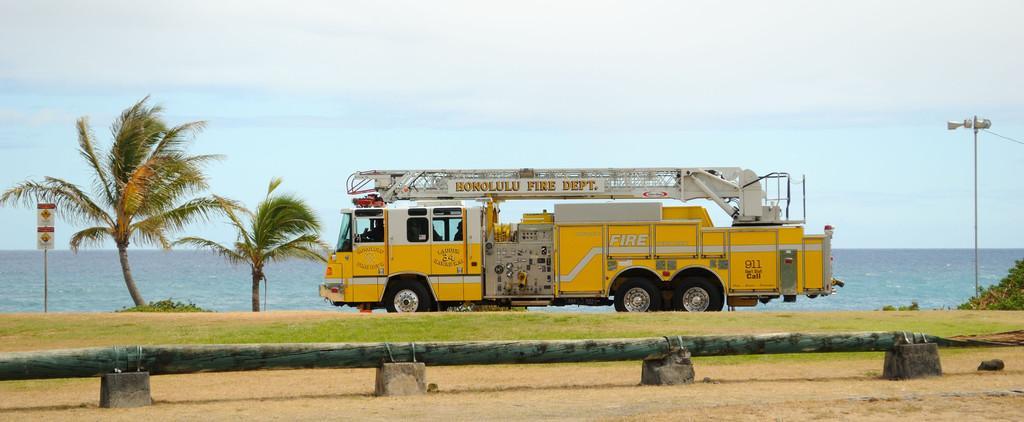How would you summarize this image in a sentence or two? In this image we can see a vehicle on the ground, there are trees in front of the vehicle and a board to the pole near the trees, there is a light pole, a wooden log on the stones and there is water and the sky in the background. 